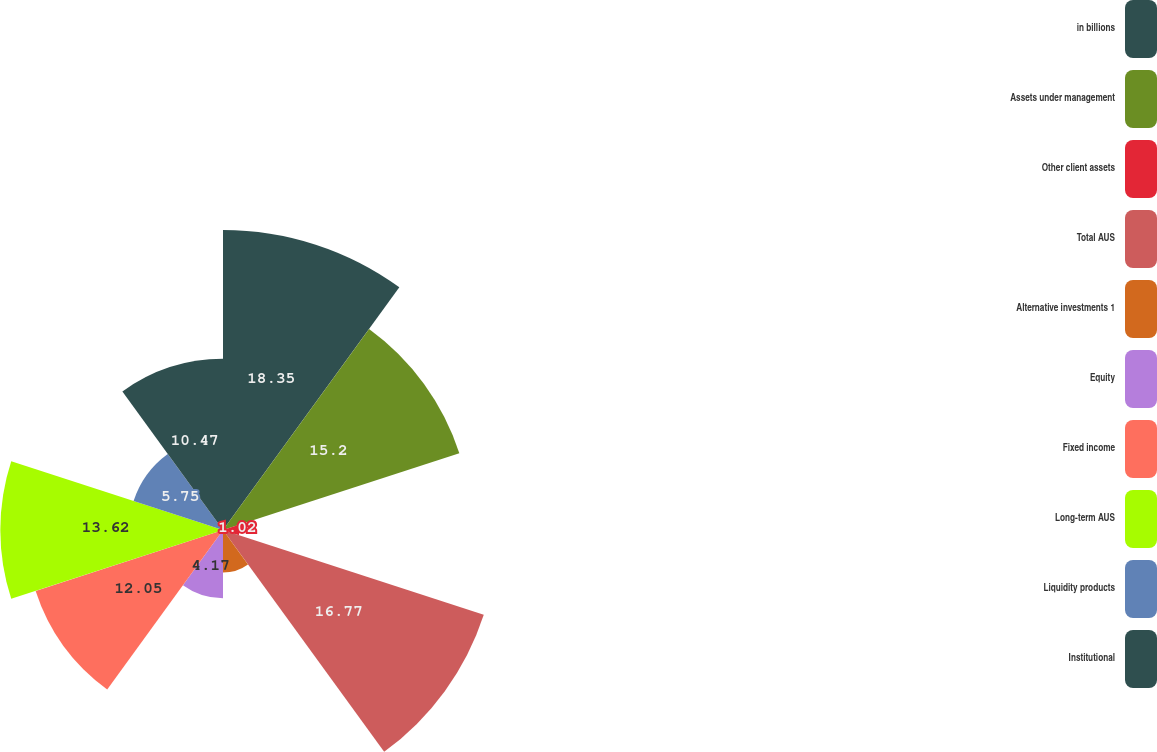Convert chart to OTSL. <chart><loc_0><loc_0><loc_500><loc_500><pie_chart><fcel>in billions<fcel>Assets under management<fcel>Other client assets<fcel>Total AUS<fcel>Alternative investments 1<fcel>Equity<fcel>Fixed income<fcel>Long-term AUS<fcel>Liquidity products<fcel>Institutional<nl><fcel>18.35%<fcel>15.2%<fcel>1.02%<fcel>16.77%<fcel>2.6%<fcel>4.17%<fcel>12.05%<fcel>13.62%<fcel>5.75%<fcel>10.47%<nl></chart> 